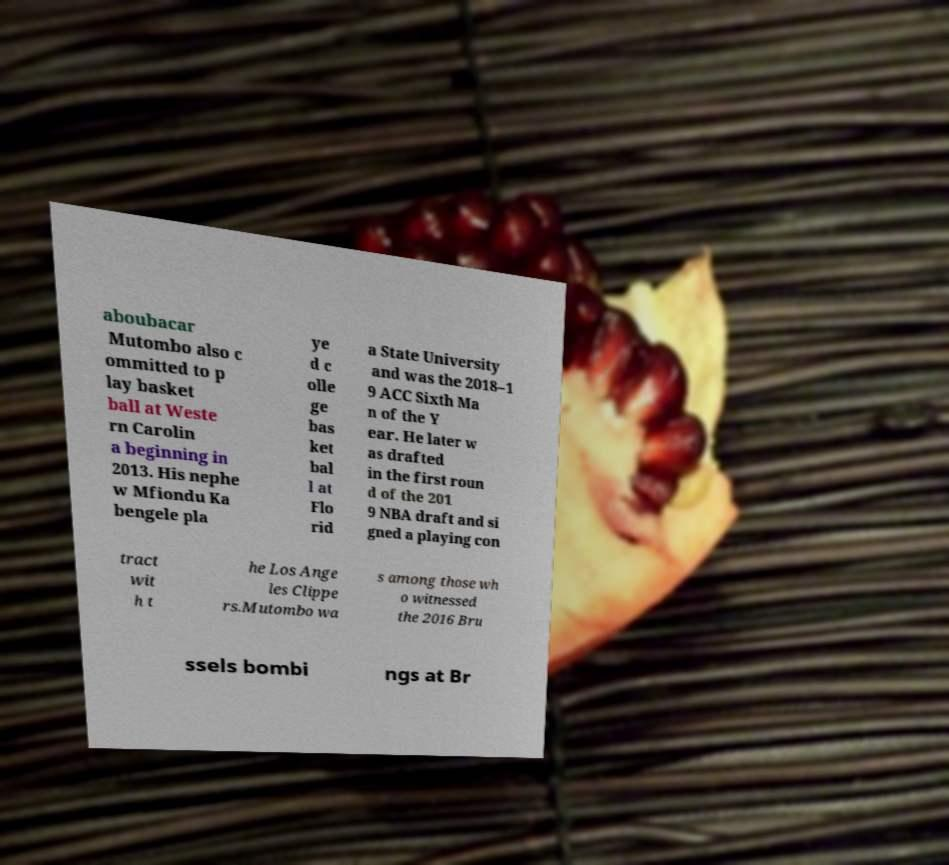Please read and relay the text visible in this image. What does it say? aboubacar Mutombo also c ommitted to p lay basket ball at Weste rn Carolin a beginning in 2013. His nephe w Mfiondu Ka bengele pla ye d c olle ge bas ket bal l at Flo rid a State University and was the 2018–1 9 ACC Sixth Ma n of the Y ear. He later w as drafted in the first roun d of the 201 9 NBA draft and si gned a playing con tract wit h t he Los Ange les Clippe rs.Mutombo wa s among those wh o witnessed the 2016 Bru ssels bombi ngs at Br 